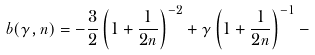Convert formula to latex. <formula><loc_0><loc_0><loc_500><loc_500>b ( \gamma , n ) = - \frac { 3 } { 2 } \left ( 1 + \frac { 1 } { 2 n } \right ) ^ { - 2 } + \gamma \left ( 1 + \frac { 1 } { 2 n } \right ) ^ { - 1 } -</formula> 